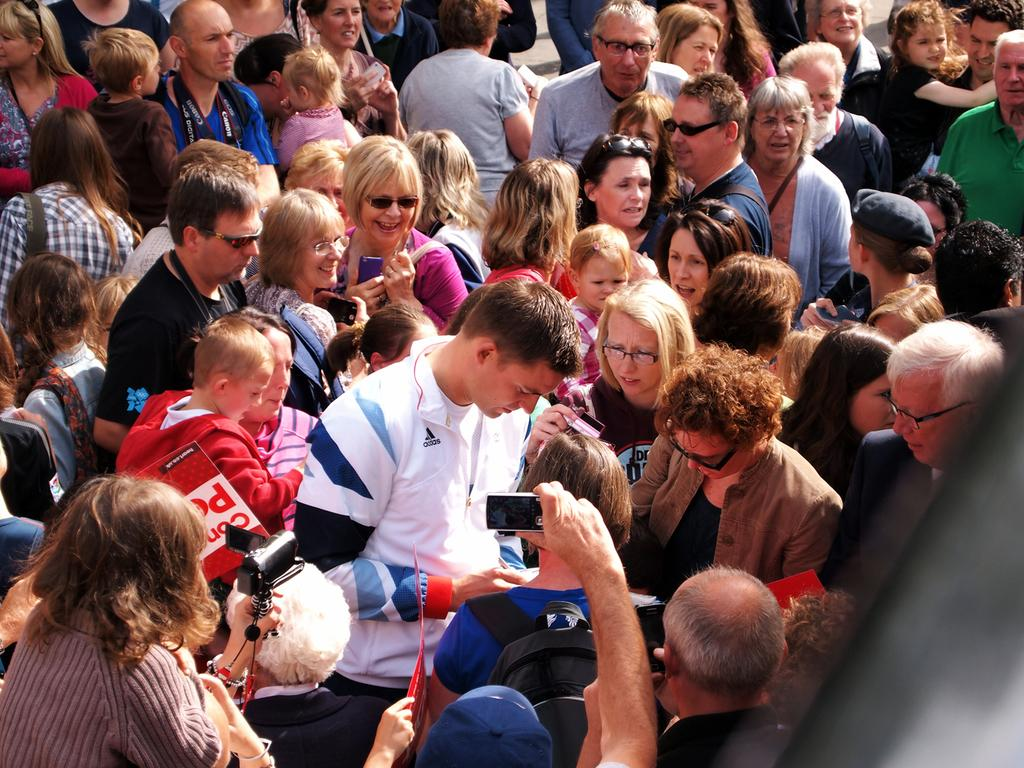How many people are in the image? There is a group of people in the image. What are some of the people in the group doing? Some people in the group are standing. What are the people holding in the image? Some people in the group are holding objects. What is the reaction of the person in the image to the protest happening nearby? There is no mention of a protest in the image, and no specific person is identified, so it is not possible to answer this question. 